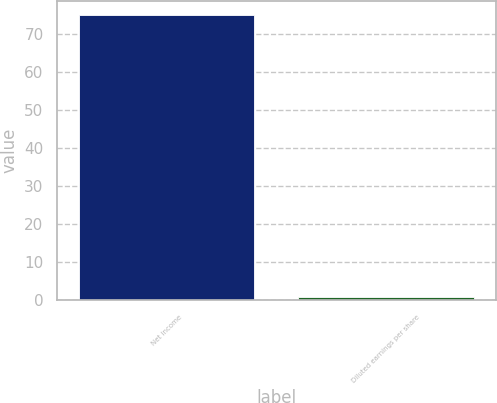<chart> <loc_0><loc_0><loc_500><loc_500><bar_chart><fcel>Net income<fcel>Diluted earnings per share<nl><fcel>75<fcel>0.79<nl></chart> 